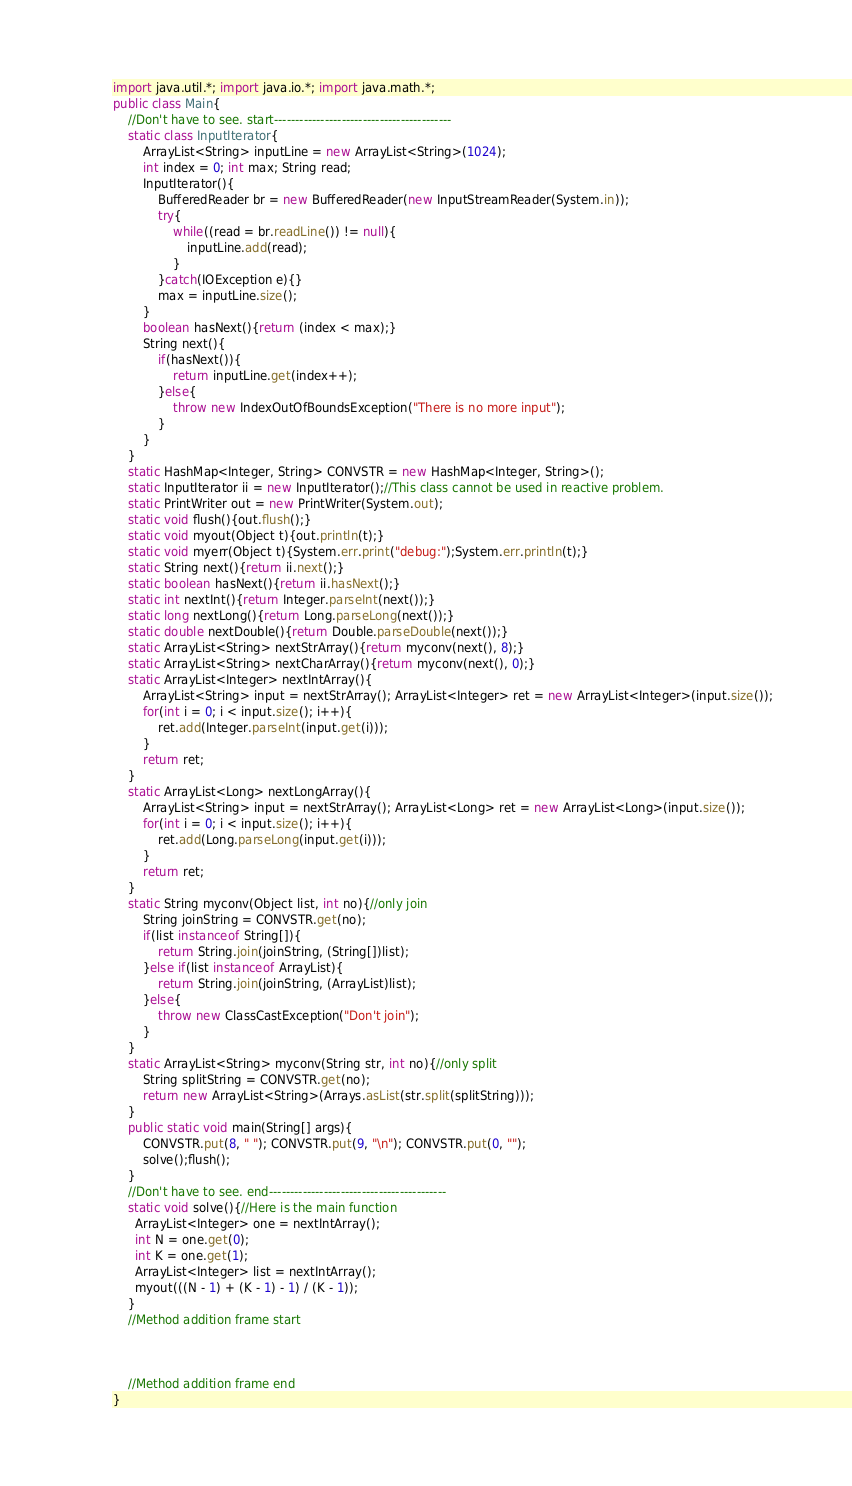<code> <loc_0><loc_0><loc_500><loc_500><_Java_>import java.util.*; import java.io.*; import java.math.*;
public class Main{
	//Don't have to see. start------------------------------------------
	static class InputIterator{
		ArrayList<String> inputLine = new ArrayList<String>(1024);
		int index = 0; int max; String read;
		InputIterator(){
			BufferedReader br = new BufferedReader(new InputStreamReader(System.in));
			try{
				while((read = br.readLine()) != null){
					inputLine.add(read);
				}
			}catch(IOException e){}
			max = inputLine.size();
		}
		boolean hasNext(){return (index < max);}
		String next(){
			if(hasNext()){
				return inputLine.get(index++);
			}else{
				throw new IndexOutOfBoundsException("There is no more input");
			}
		}
	}
	static HashMap<Integer, String> CONVSTR = new HashMap<Integer, String>();
	static InputIterator ii = new InputIterator();//This class cannot be used in reactive problem.
	static PrintWriter out = new PrintWriter(System.out);
	static void flush(){out.flush();}
	static void myout(Object t){out.println(t);}
	static void myerr(Object t){System.err.print("debug:");System.err.println(t);}
	static String next(){return ii.next();}
	static boolean hasNext(){return ii.hasNext();}
	static int nextInt(){return Integer.parseInt(next());}
	static long nextLong(){return Long.parseLong(next());}
	static double nextDouble(){return Double.parseDouble(next());}
	static ArrayList<String> nextStrArray(){return myconv(next(), 8);}
	static ArrayList<String> nextCharArray(){return myconv(next(), 0);}
	static ArrayList<Integer> nextIntArray(){
		ArrayList<String> input = nextStrArray(); ArrayList<Integer> ret = new ArrayList<Integer>(input.size());
		for(int i = 0; i < input.size(); i++){
			ret.add(Integer.parseInt(input.get(i)));
		}
		return ret;
	}
	static ArrayList<Long> nextLongArray(){
		ArrayList<String> input = nextStrArray(); ArrayList<Long> ret = new ArrayList<Long>(input.size());
		for(int i = 0; i < input.size(); i++){
			ret.add(Long.parseLong(input.get(i)));
		}
		return ret;
	}
	static String myconv(Object list, int no){//only join
		String joinString = CONVSTR.get(no);
		if(list instanceof String[]){
			return String.join(joinString, (String[])list);
		}else if(list instanceof ArrayList){
			return String.join(joinString, (ArrayList)list);
		}else{
			throw new ClassCastException("Don't join");
		}
	}
	static ArrayList<String> myconv(String str, int no){//only split
		String splitString = CONVSTR.get(no);
		return new ArrayList<String>(Arrays.asList(str.split(splitString)));
	}
	public static void main(String[] args){
		CONVSTR.put(8, " "); CONVSTR.put(9, "\n"); CONVSTR.put(0, "");
		solve();flush();
	}
	//Don't have to see. end------------------------------------------
	static void solve(){//Here is the main function
      ArrayList<Integer> one = nextIntArray();
      int N = one.get(0);
      int K = one.get(1);
      ArrayList<Integer> list = nextIntArray();
      myout(((N - 1) + (K - 1) - 1) / (K - 1));
	}
	//Method addition frame start



	//Method addition frame end
}
</code> 